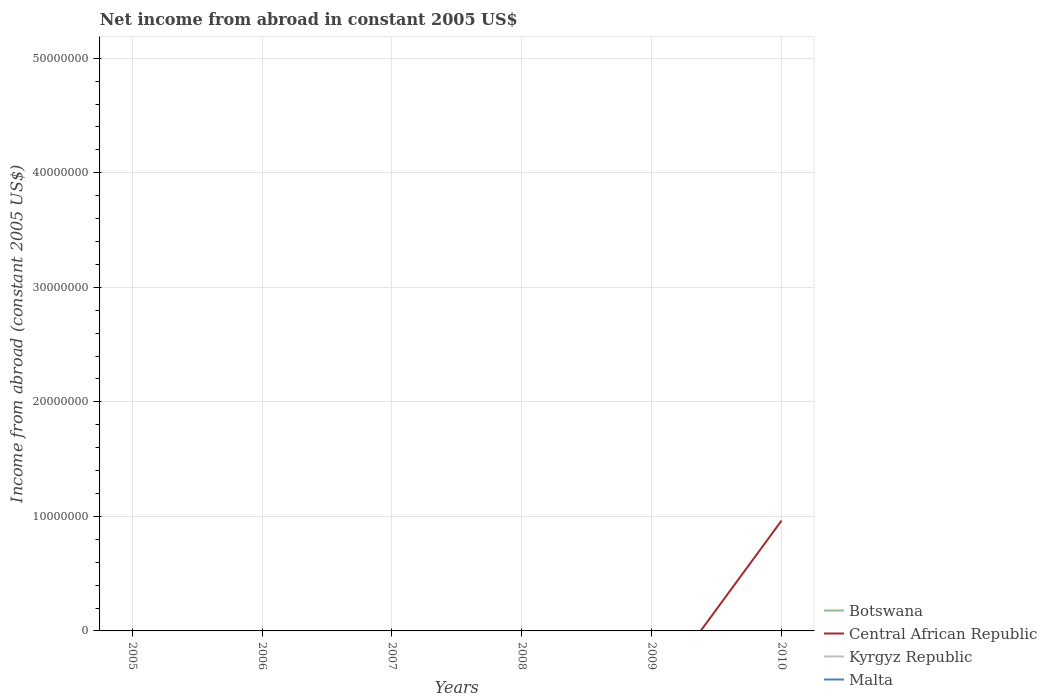What is the difference between the highest and the second highest net income from abroad in Central African Republic?
Make the answer very short. 9.63e+06. What is the difference between the highest and the lowest net income from abroad in Botswana?
Your answer should be compact. 0. Are the values on the major ticks of Y-axis written in scientific E-notation?
Your response must be concise. No. Does the graph contain grids?
Ensure brevity in your answer.  Yes. Where does the legend appear in the graph?
Provide a short and direct response. Bottom right. How many legend labels are there?
Your answer should be compact. 4. How are the legend labels stacked?
Keep it short and to the point. Vertical. What is the title of the graph?
Keep it short and to the point. Net income from abroad in constant 2005 US$. What is the label or title of the Y-axis?
Keep it short and to the point. Income from abroad (constant 2005 US$). What is the Income from abroad (constant 2005 US$) of Botswana in 2005?
Your answer should be compact. 0. What is the Income from abroad (constant 2005 US$) in Central African Republic in 2005?
Your answer should be very brief. 0. What is the Income from abroad (constant 2005 US$) of Kyrgyz Republic in 2005?
Offer a very short reply. 0. What is the Income from abroad (constant 2005 US$) of Malta in 2005?
Your answer should be very brief. 0. What is the Income from abroad (constant 2005 US$) of Botswana in 2006?
Offer a very short reply. 0. What is the Income from abroad (constant 2005 US$) of Kyrgyz Republic in 2006?
Give a very brief answer. 0. What is the Income from abroad (constant 2005 US$) in Botswana in 2007?
Offer a terse response. 0. What is the Income from abroad (constant 2005 US$) of Botswana in 2008?
Provide a short and direct response. 0. What is the Income from abroad (constant 2005 US$) in Botswana in 2009?
Offer a very short reply. 0. What is the Income from abroad (constant 2005 US$) in Kyrgyz Republic in 2009?
Give a very brief answer. 0. What is the Income from abroad (constant 2005 US$) in Central African Republic in 2010?
Your answer should be very brief. 9.63e+06. What is the Income from abroad (constant 2005 US$) of Malta in 2010?
Offer a terse response. 0. Across all years, what is the maximum Income from abroad (constant 2005 US$) of Central African Republic?
Your answer should be very brief. 9.63e+06. What is the total Income from abroad (constant 2005 US$) of Botswana in the graph?
Your answer should be compact. 0. What is the total Income from abroad (constant 2005 US$) of Central African Republic in the graph?
Provide a succinct answer. 9.63e+06. What is the total Income from abroad (constant 2005 US$) of Kyrgyz Republic in the graph?
Provide a short and direct response. 0. What is the total Income from abroad (constant 2005 US$) of Malta in the graph?
Give a very brief answer. 0. What is the average Income from abroad (constant 2005 US$) in Central African Republic per year?
Provide a short and direct response. 1.61e+06. What is the average Income from abroad (constant 2005 US$) in Kyrgyz Republic per year?
Give a very brief answer. 0. What is the average Income from abroad (constant 2005 US$) of Malta per year?
Offer a terse response. 0. What is the difference between the highest and the lowest Income from abroad (constant 2005 US$) in Central African Republic?
Give a very brief answer. 9.63e+06. 